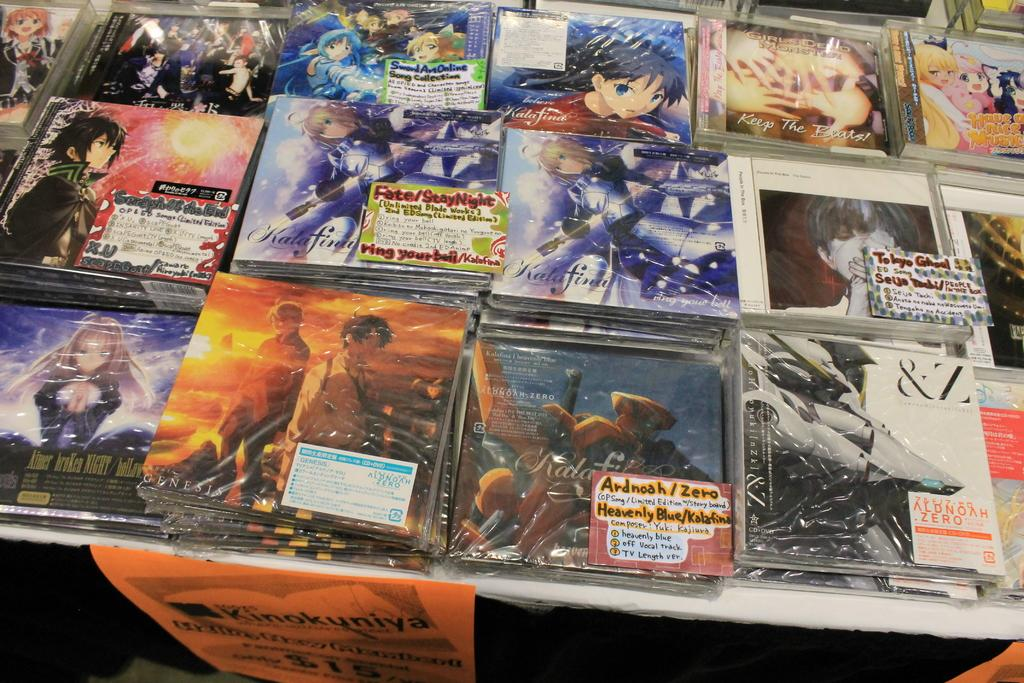<image>
Offer a succinct explanation of the picture presented. A collection of Anime Comic movies one reads Ardnoah/Zero. 